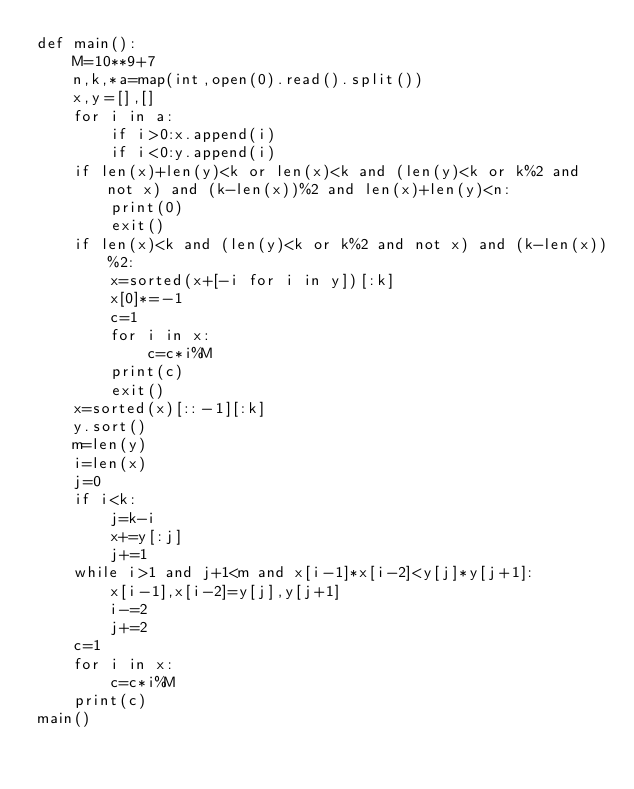<code> <loc_0><loc_0><loc_500><loc_500><_Python_>def main():
    M=10**9+7
    n,k,*a=map(int,open(0).read().split())
    x,y=[],[]
    for i in a:
        if i>0:x.append(i)
        if i<0:y.append(i)
    if len(x)+len(y)<k or len(x)<k and (len(y)<k or k%2 and not x) and (k-len(x))%2 and len(x)+len(y)<n:
        print(0)
        exit()
    if len(x)<k and (len(y)<k or k%2 and not x) and (k-len(x))%2:
        x=sorted(x+[-i for i in y])[:k]
        x[0]*=-1
        c=1
        for i in x:
            c=c*i%M
        print(c)
        exit()
    x=sorted(x)[::-1][:k]
    y.sort()
    m=len(y)
    i=len(x)
    j=0
    if i<k:
        j=k-i
        x+=y[:j]
        j+=1
    while i>1 and j+1<m and x[i-1]*x[i-2]<y[j]*y[j+1]:
        x[i-1],x[i-2]=y[j],y[j+1]
        i-=2
        j+=2
    c=1
    for i in x:
        c=c*i%M
    print(c)
main()</code> 